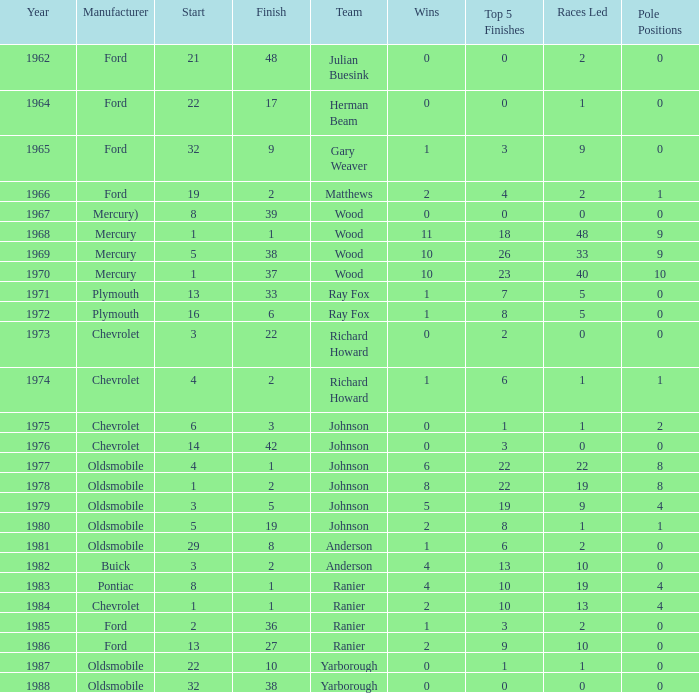What is the smallest finish time for a race after 1972 with a car manufactured by pontiac? 1.0. 